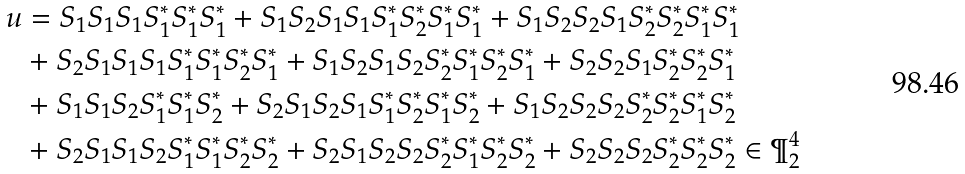<formula> <loc_0><loc_0><loc_500><loc_500>u & = S _ { 1 } S _ { 1 } S _ { 1 } S _ { 1 } ^ { * } S _ { 1 } ^ { * } S _ { 1 } ^ { * } + S _ { 1 } S _ { 2 } S _ { 1 } S _ { 1 } S _ { 1 } ^ { * } S _ { 2 } ^ { * } S _ { 1 } ^ { * } S _ { 1 } ^ { * } + S _ { 1 } S _ { 2 } S _ { 2 } S _ { 1 } S _ { 2 } ^ { * } S _ { 2 } ^ { * } S _ { 1 } ^ { * } S _ { 1 } ^ { * } \\ & + S _ { 2 } S _ { 1 } S _ { 1 } S _ { 1 } S _ { 1 } ^ { * } S _ { 1 } ^ { * } S _ { 2 } ^ { * } S _ { 1 } ^ { * } + S _ { 1 } S _ { 2 } S _ { 1 } S _ { 2 } S _ { 2 } ^ { * } S _ { 1 } ^ { * } S _ { 2 } ^ { * } S _ { 1 } ^ { * } + S _ { 2 } S _ { 2 } S _ { 1 } S _ { 2 } ^ { * } S _ { 2 } ^ { * } S _ { 1 } ^ { * } \\ & + S _ { 1 } S _ { 1 } S _ { 2 } S _ { 1 } ^ { * } S _ { 1 } ^ { * } S _ { 2 } ^ { * } + S _ { 2 } S _ { 1 } S _ { 2 } S _ { 1 } S _ { 1 } ^ { * } S _ { 2 } ^ { * } S _ { 1 } ^ { * } S _ { 2 } ^ { * } + S _ { 1 } S _ { 2 } S _ { 2 } S _ { 2 } S _ { 2 } ^ { * } S _ { 2 } ^ { * } S _ { 1 } ^ { * } S _ { 2 } ^ { * } \\ & + S _ { 2 } S _ { 1 } S _ { 1 } S _ { 2 } S _ { 1 } ^ { * } S _ { 1 } ^ { * } S _ { 2 } ^ { * } S _ { 2 } ^ { * } + S _ { 2 } S _ { 1 } S _ { 2 } S _ { 2 } S _ { 2 } ^ { * } S _ { 1 } ^ { * } S _ { 2 } ^ { * } S _ { 2 } ^ { * } + S _ { 2 } S _ { 2 } S _ { 2 } S _ { 2 } ^ { * } S _ { 2 } ^ { * } S _ { 2 } ^ { * } \in \P _ { 2 } ^ { 4 }</formula> 